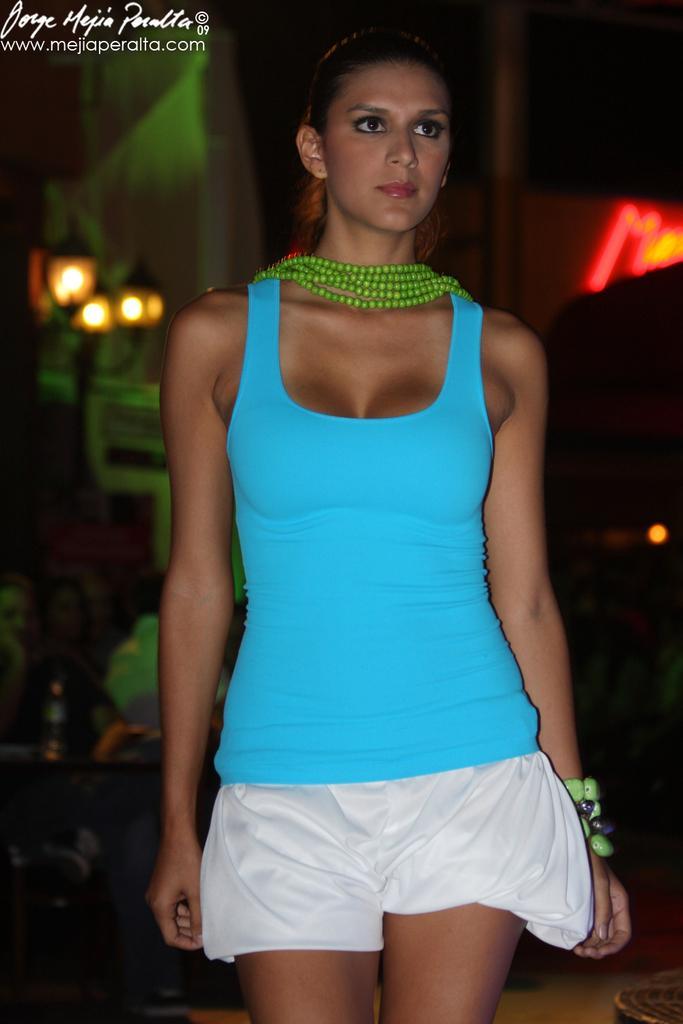Please provide a concise description of this image. This is a zoomed in picture. In the foreground there is a woman wearing blue color t-shirt and seems to be walking on the ground. In the background we can see the lights and many other objects. In the bottom left corner there is a text on the image. 